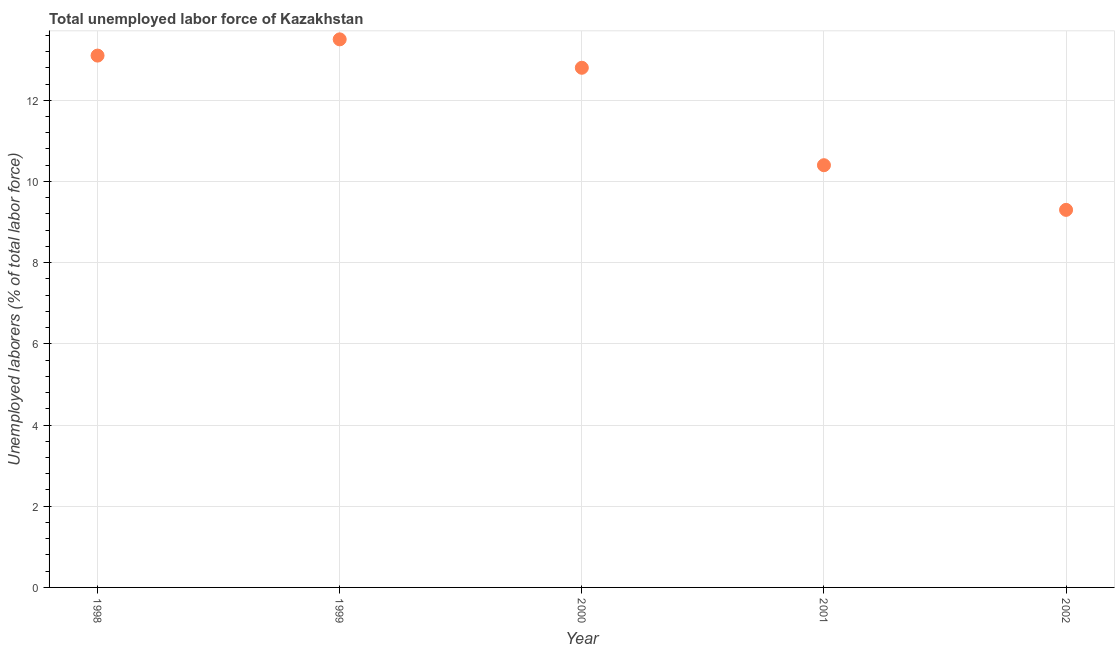What is the total unemployed labour force in 2000?
Offer a very short reply. 12.8. Across all years, what is the maximum total unemployed labour force?
Your answer should be very brief. 13.5. Across all years, what is the minimum total unemployed labour force?
Provide a short and direct response. 9.3. What is the sum of the total unemployed labour force?
Make the answer very short. 59.1. What is the difference between the total unemployed labour force in 1998 and 1999?
Your answer should be very brief. -0.4. What is the average total unemployed labour force per year?
Provide a short and direct response. 11.82. What is the median total unemployed labour force?
Your response must be concise. 12.8. In how many years, is the total unemployed labour force greater than 0.8 %?
Give a very brief answer. 5. Do a majority of the years between 2001 and 1998 (inclusive) have total unemployed labour force greater than 2.8 %?
Provide a succinct answer. Yes. What is the ratio of the total unemployed labour force in 2000 to that in 2001?
Your answer should be very brief. 1.23. Is the total unemployed labour force in 2001 less than that in 2002?
Your answer should be compact. No. Is the difference between the total unemployed labour force in 1998 and 2000 greater than the difference between any two years?
Give a very brief answer. No. What is the difference between the highest and the second highest total unemployed labour force?
Offer a very short reply. 0.4. Is the sum of the total unemployed labour force in 1998 and 2000 greater than the maximum total unemployed labour force across all years?
Make the answer very short. Yes. What is the difference between the highest and the lowest total unemployed labour force?
Your response must be concise. 4.2. Does the total unemployed labour force monotonically increase over the years?
Make the answer very short. No. What is the difference between two consecutive major ticks on the Y-axis?
Give a very brief answer. 2. Are the values on the major ticks of Y-axis written in scientific E-notation?
Your answer should be compact. No. Does the graph contain grids?
Your answer should be compact. Yes. What is the title of the graph?
Ensure brevity in your answer.  Total unemployed labor force of Kazakhstan. What is the label or title of the Y-axis?
Offer a very short reply. Unemployed laborers (% of total labor force). What is the Unemployed laborers (% of total labor force) in 1998?
Provide a succinct answer. 13.1. What is the Unemployed laborers (% of total labor force) in 1999?
Offer a terse response. 13.5. What is the Unemployed laborers (% of total labor force) in 2000?
Keep it short and to the point. 12.8. What is the Unemployed laborers (% of total labor force) in 2001?
Give a very brief answer. 10.4. What is the Unemployed laborers (% of total labor force) in 2002?
Your answer should be compact. 9.3. What is the difference between the Unemployed laborers (% of total labor force) in 1998 and 1999?
Provide a succinct answer. -0.4. What is the difference between the Unemployed laborers (% of total labor force) in 1998 and 2002?
Provide a short and direct response. 3.8. What is the difference between the Unemployed laborers (% of total labor force) in 1999 and 2000?
Make the answer very short. 0.7. What is the difference between the Unemployed laborers (% of total labor force) in 1999 and 2002?
Offer a terse response. 4.2. What is the difference between the Unemployed laborers (% of total labor force) in 2000 and 2002?
Offer a terse response. 3.5. What is the ratio of the Unemployed laborers (% of total labor force) in 1998 to that in 1999?
Your answer should be very brief. 0.97. What is the ratio of the Unemployed laborers (% of total labor force) in 1998 to that in 2000?
Offer a very short reply. 1.02. What is the ratio of the Unemployed laborers (% of total labor force) in 1998 to that in 2001?
Offer a very short reply. 1.26. What is the ratio of the Unemployed laborers (% of total labor force) in 1998 to that in 2002?
Your answer should be compact. 1.41. What is the ratio of the Unemployed laborers (% of total labor force) in 1999 to that in 2000?
Ensure brevity in your answer.  1.05. What is the ratio of the Unemployed laborers (% of total labor force) in 1999 to that in 2001?
Offer a very short reply. 1.3. What is the ratio of the Unemployed laborers (% of total labor force) in 1999 to that in 2002?
Ensure brevity in your answer.  1.45. What is the ratio of the Unemployed laborers (% of total labor force) in 2000 to that in 2001?
Offer a very short reply. 1.23. What is the ratio of the Unemployed laborers (% of total labor force) in 2000 to that in 2002?
Your response must be concise. 1.38. What is the ratio of the Unemployed laborers (% of total labor force) in 2001 to that in 2002?
Offer a terse response. 1.12. 